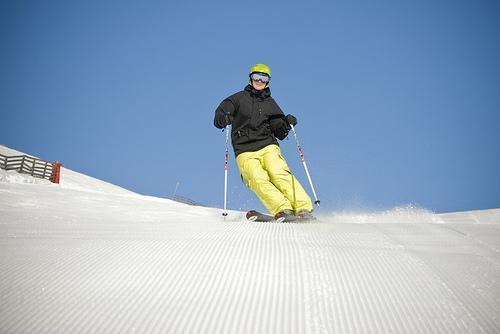How many people are there?
Give a very brief answer. 1. 